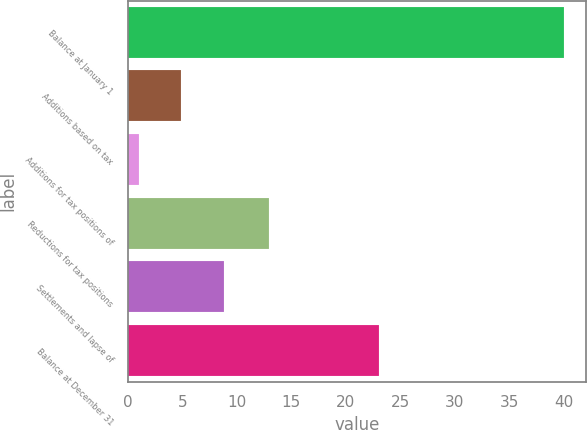<chart> <loc_0><loc_0><loc_500><loc_500><bar_chart><fcel>Balance at January 1<fcel>Additions based on tax<fcel>Additions for tax positions of<fcel>Reductions for tax positions<fcel>Settlements and lapse of<fcel>Balance at December 31<nl><fcel>40<fcel>4.9<fcel>1<fcel>13<fcel>8.8<fcel>23<nl></chart> 